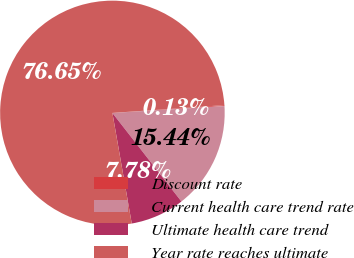<chart> <loc_0><loc_0><loc_500><loc_500><pie_chart><fcel>Discount rate<fcel>Current health care trend rate<fcel>Ultimate health care trend<fcel>Year rate reaches ultimate<nl><fcel>0.13%<fcel>15.44%<fcel>7.78%<fcel>76.65%<nl></chart> 